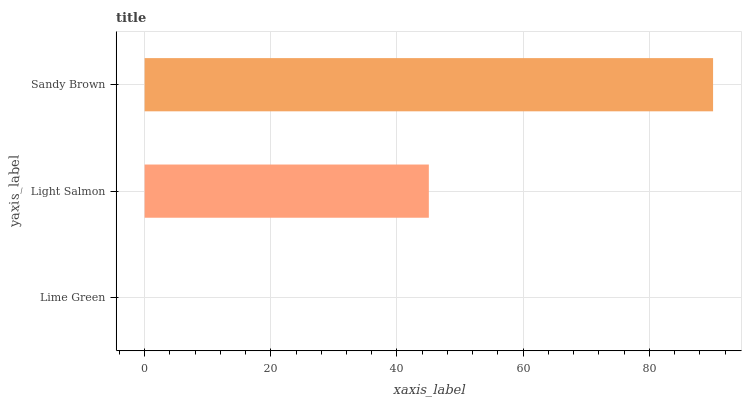Is Lime Green the minimum?
Answer yes or no. Yes. Is Sandy Brown the maximum?
Answer yes or no. Yes. Is Light Salmon the minimum?
Answer yes or no. No. Is Light Salmon the maximum?
Answer yes or no. No. Is Light Salmon greater than Lime Green?
Answer yes or no. Yes. Is Lime Green less than Light Salmon?
Answer yes or no. Yes. Is Lime Green greater than Light Salmon?
Answer yes or no. No. Is Light Salmon less than Lime Green?
Answer yes or no. No. Is Light Salmon the high median?
Answer yes or no. Yes. Is Light Salmon the low median?
Answer yes or no. Yes. Is Sandy Brown the high median?
Answer yes or no. No. Is Lime Green the low median?
Answer yes or no. No. 